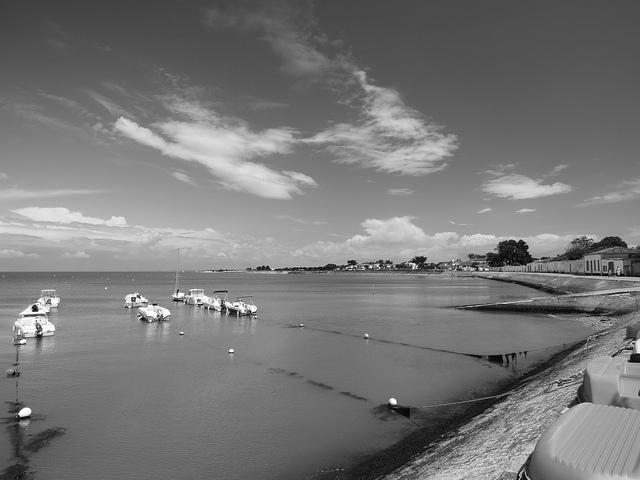What vehicles are located in the water? boats 